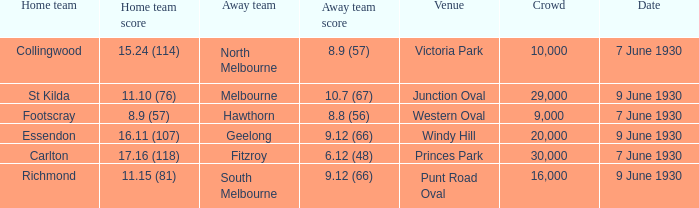What is the average crowd size when North Melbourne is the away team? 10000.0. 